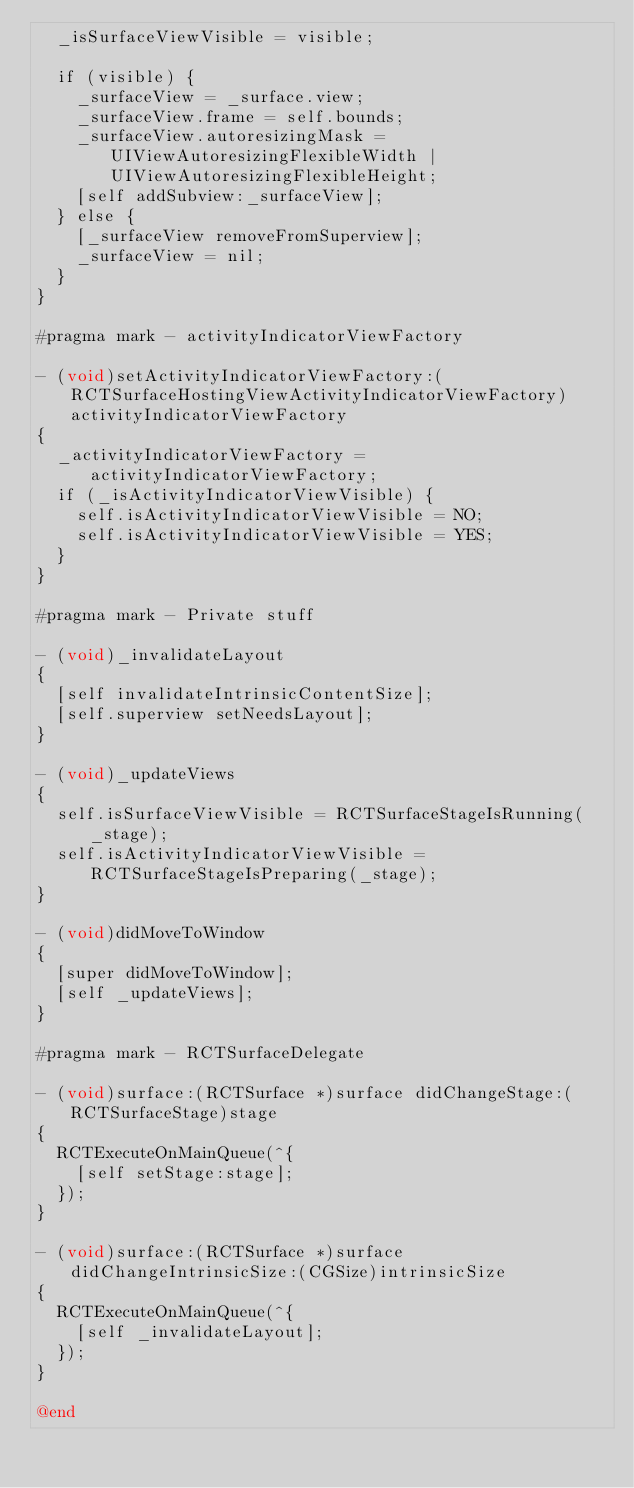Convert code to text. <code><loc_0><loc_0><loc_500><loc_500><_ObjectiveC_>  _isSurfaceViewVisible = visible;

  if (visible) {
    _surfaceView = _surface.view;
    _surfaceView.frame = self.bounds;
    _surfaceView.autoresizingMask = UIViewAutoresizingFlexibleWidth | UIViewAutoresizingFlexibleHeight;
    [self addSubview:_surfaceView];
  } else {
    [_surfaceView removeFromSuperview];
    _surfaceView = nil;
  }
}

#pragma mark - activityIndicatorViewFactory

- (void)setActivityIndicatorViewFactory:(RCTSurfaceHostingViewActivityIndicatorViewFactory)activityIndicatorViewFactory
{
  _activityIndicatorViewFactory = activityIndicatorViewFactory;
  if (_isActivityIndicatorViewVisible) {
    self.isActivityIndicatorViewVisible = NO;
    self.isActivityIndicatorViewVisible = YES;
  }
}

#pragma mark - Private stuff

- (void)_invalidateLayout
{
  [self invalidateIntrinsicContentSize];
  [self.superview setNeedsLayout];
}

- (void)_updateViews
{
  self.isSurfaceViewVisible = RCTSurfaceStageIsRunning(_stage);
  self.isActivityIndicatorViewVisible = RCTSurfaceStageIsPreparing(_stage);
}

- (void)didMoveToWindow
{
  [super didMoveToWindow];
  [self _updateViews];
}

#pragma mark - RCTSurfaceDelegate

- (void)surface:(RCTSurface *)surface didChangeStage:(RCTSurfaceStage)stage
{
  RCTExecuteOnMainQueue(^{
    [self setStage:stage];
  });
}

- (void)surface:(RCTSurface *)surface didChangeIntrinsicSize:(CGSize)intrinsicSize
{
  RCTExecuteOnMainQueue(^{
    [self _invalidateLayout];
  });
}

@end
</code> 